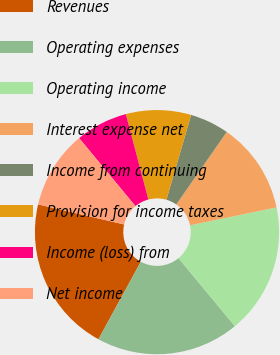<chart> <loc_0><loc_0><loc_500><loc_500><pie_chart><fcel>Revenues<fcel>Operating expenses<fcel>Operating income<fcel>Interest expense net<fcel>Income from continuing<fcel>Provision for income taxes<fcel>Income (loss) from<fcel>Net income<nl><fcel>20.69%<fcel>18.97%<fcel>17.24%<fcel>12.07%<fcel>5.17%<fcel>8.62%<fcel>6.9%<fcel>10.34%<nl></chart> 